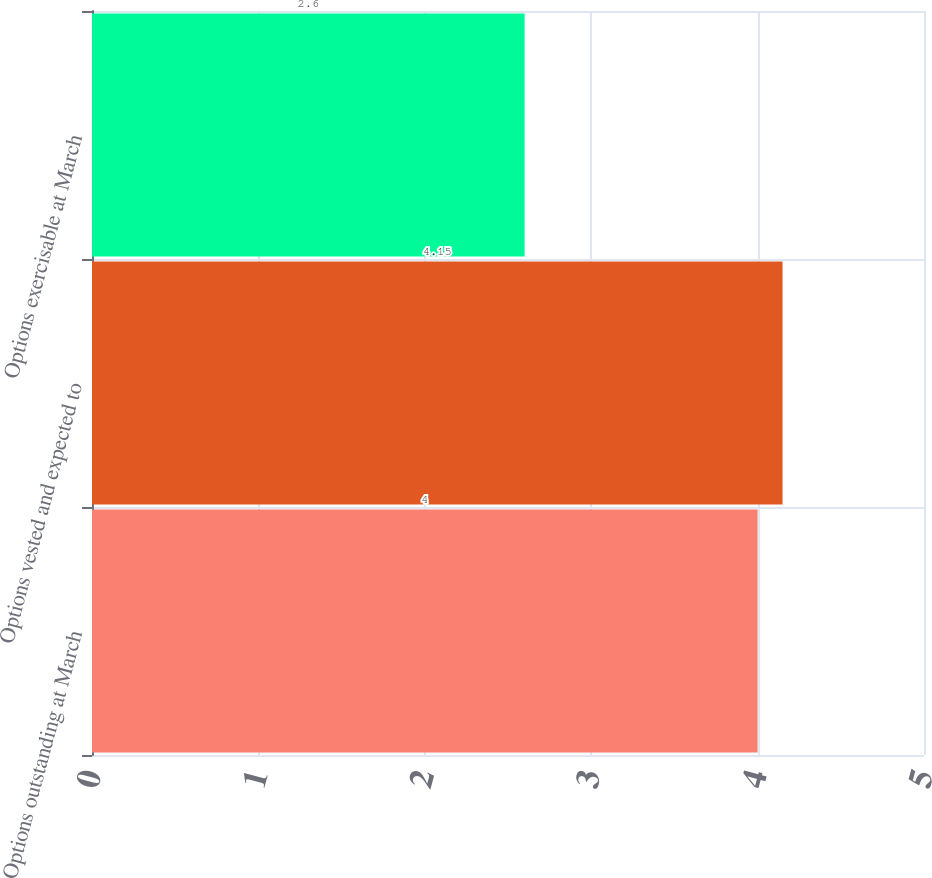Convert chart to OTSL. <chart><loc_0><loc_0><loc_500><loc_500><bar_chart><fcel>Options outstanding at March<fcel>Options vested and expected to<fcel>Options exercisable at March<nl><fcel>4<fcel>4.15<fcel>2.6<nl></chart> 